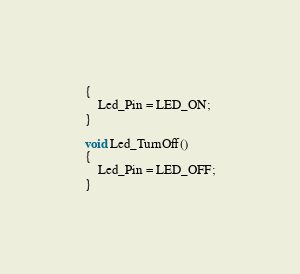Convert code to text. <code><loc_0><loc_0><loc_500><loc_500><_C_>{
    Led_Pin = LED_ON;
}

void Led_TurnOff()
{
    Led_Pin = LED_OFF;
}</code> 